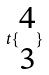Convert formula to latex. <formula><loc_0><loc_0><loc_500><loc_500>t \{ \begin{matrix} 4 \\ 3 \end{matrix} \}</formula> 